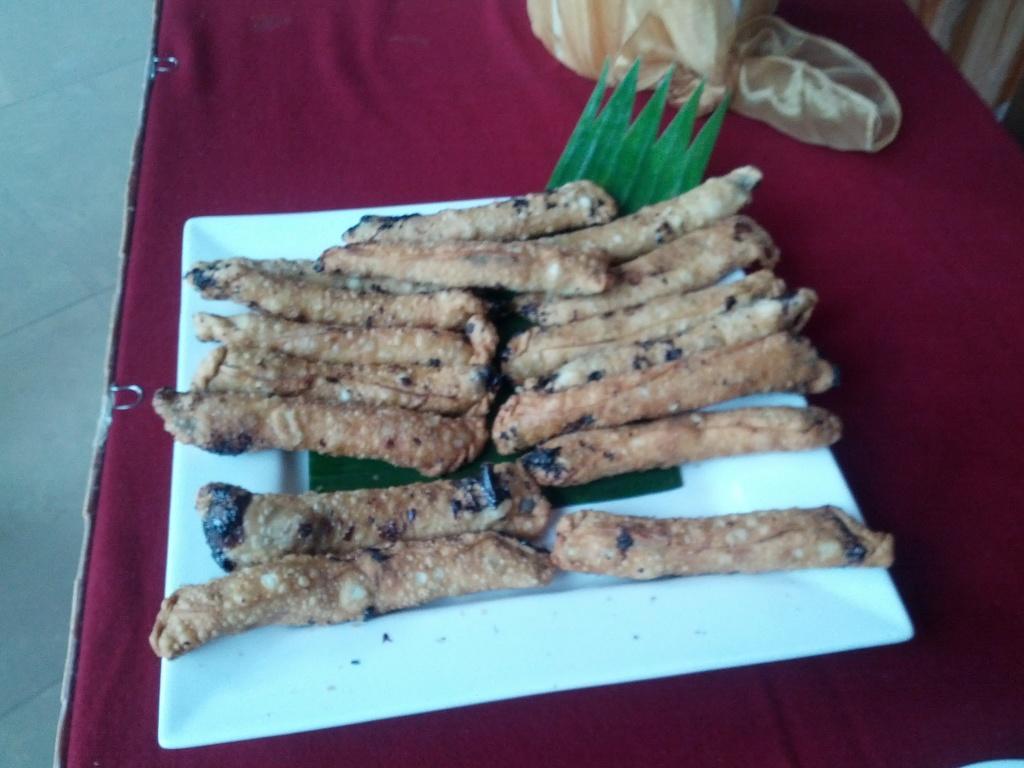How would you summarize this image in a sentence or two? In this image I can see food in the plate. The background is red in color. 